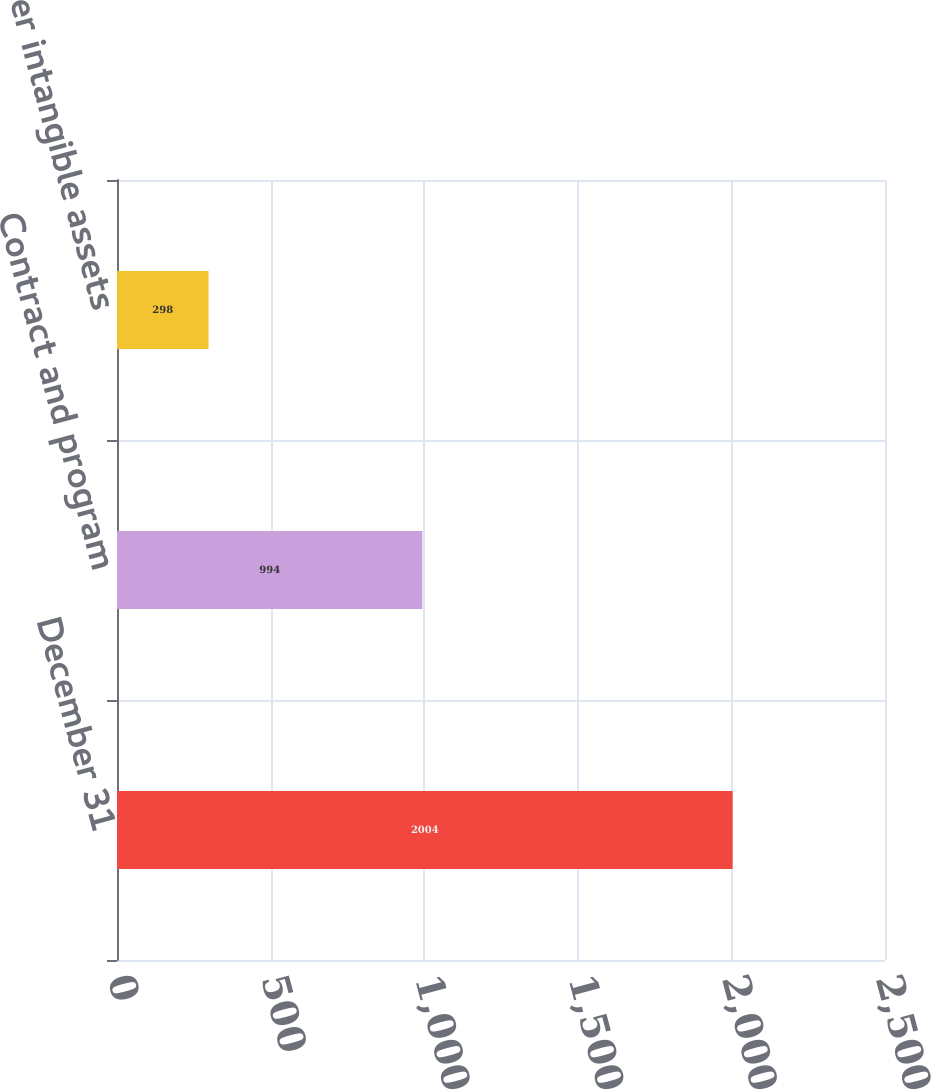Convert chart. <chart><loc_0><loc_0><loc_500><loc_500><bar_chart><fcel>December 31<fcel>Contract and program<fcel>Other intangible assets<nl><fcel>2004<fcel>994<fcel>298<nl></chart> 